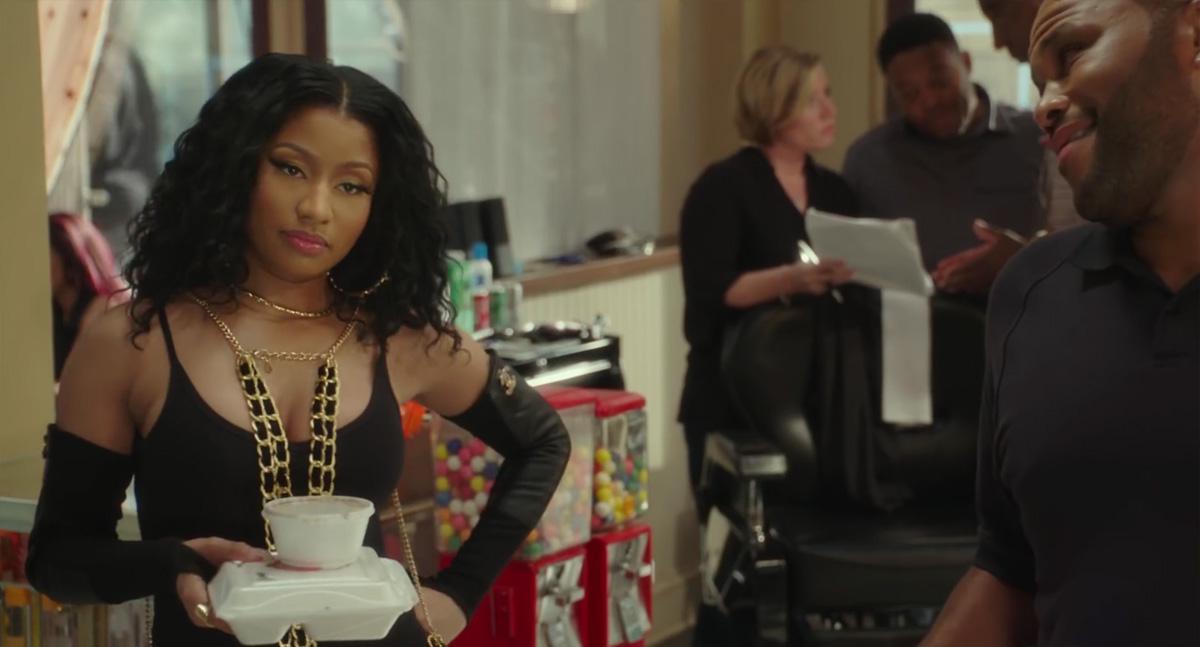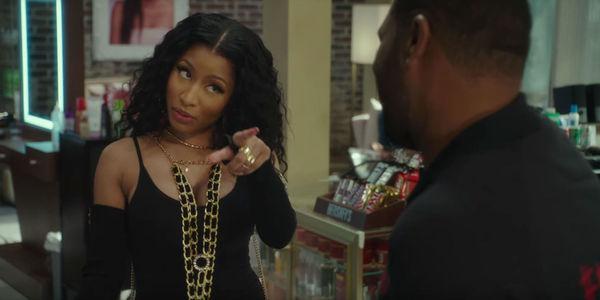The first image is the image on the left, the second image is the image on the right. Analyze the images presented: Is the assertion "There is at least one image of a man sitting in a barber chair." valid? Answer yes or no. No. The first image is the image on the left, the second image is the image on the right. Analyze the images presented: Is the assertion "The person in the right image furthest to the right has a bald scalp." valid? Answer yes or no. No. 